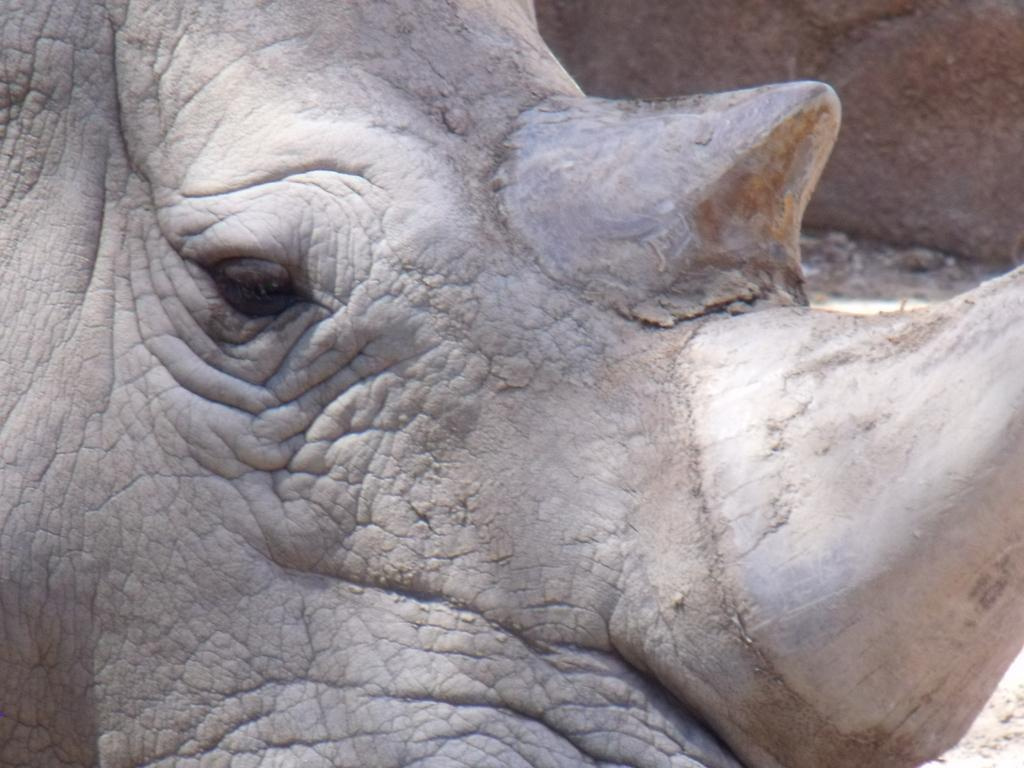What can be seen in the background of the image? There is a wall in the background of the image. What is the main focus of the image? The main highlight of the image is a partial part of a rhinoceros. What type of fuel is being used by the tree in the image? There is no tree present in the image, so it is not possible to determine what type of fuel it might be using. 